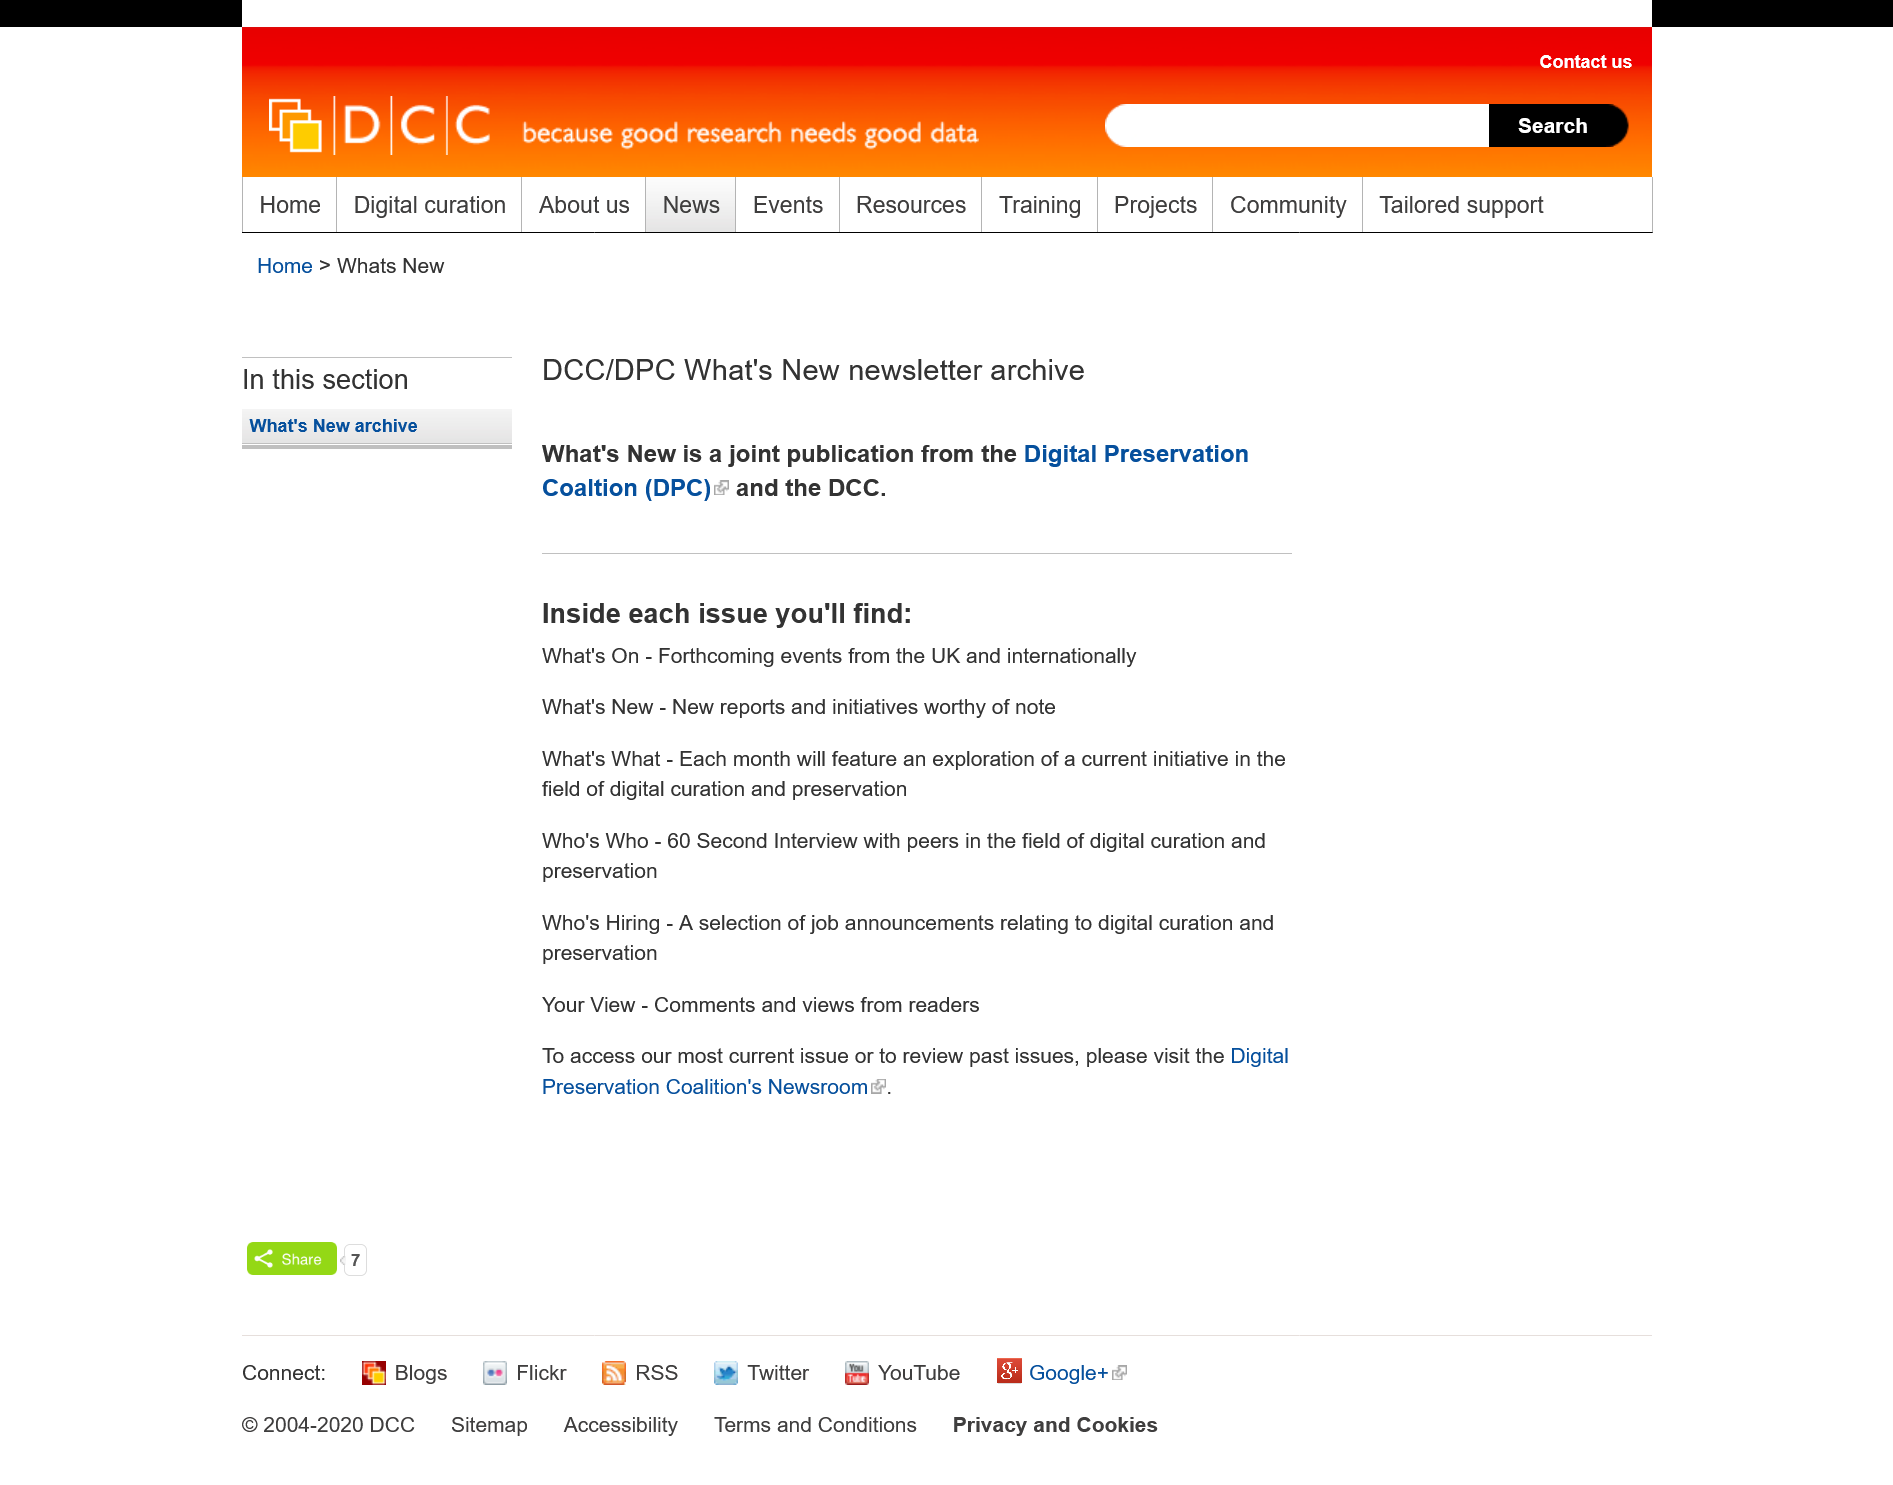Mention a couple of crucial points in this snapshot. The speaker is declaring that this is a newsletter. It is possible to locate job advertisements in every issue of the newsletter. The acronym DPC represents the Digital Preservation Coalition, a notable organization dedicated to promoting and preserving digital resources and information. 